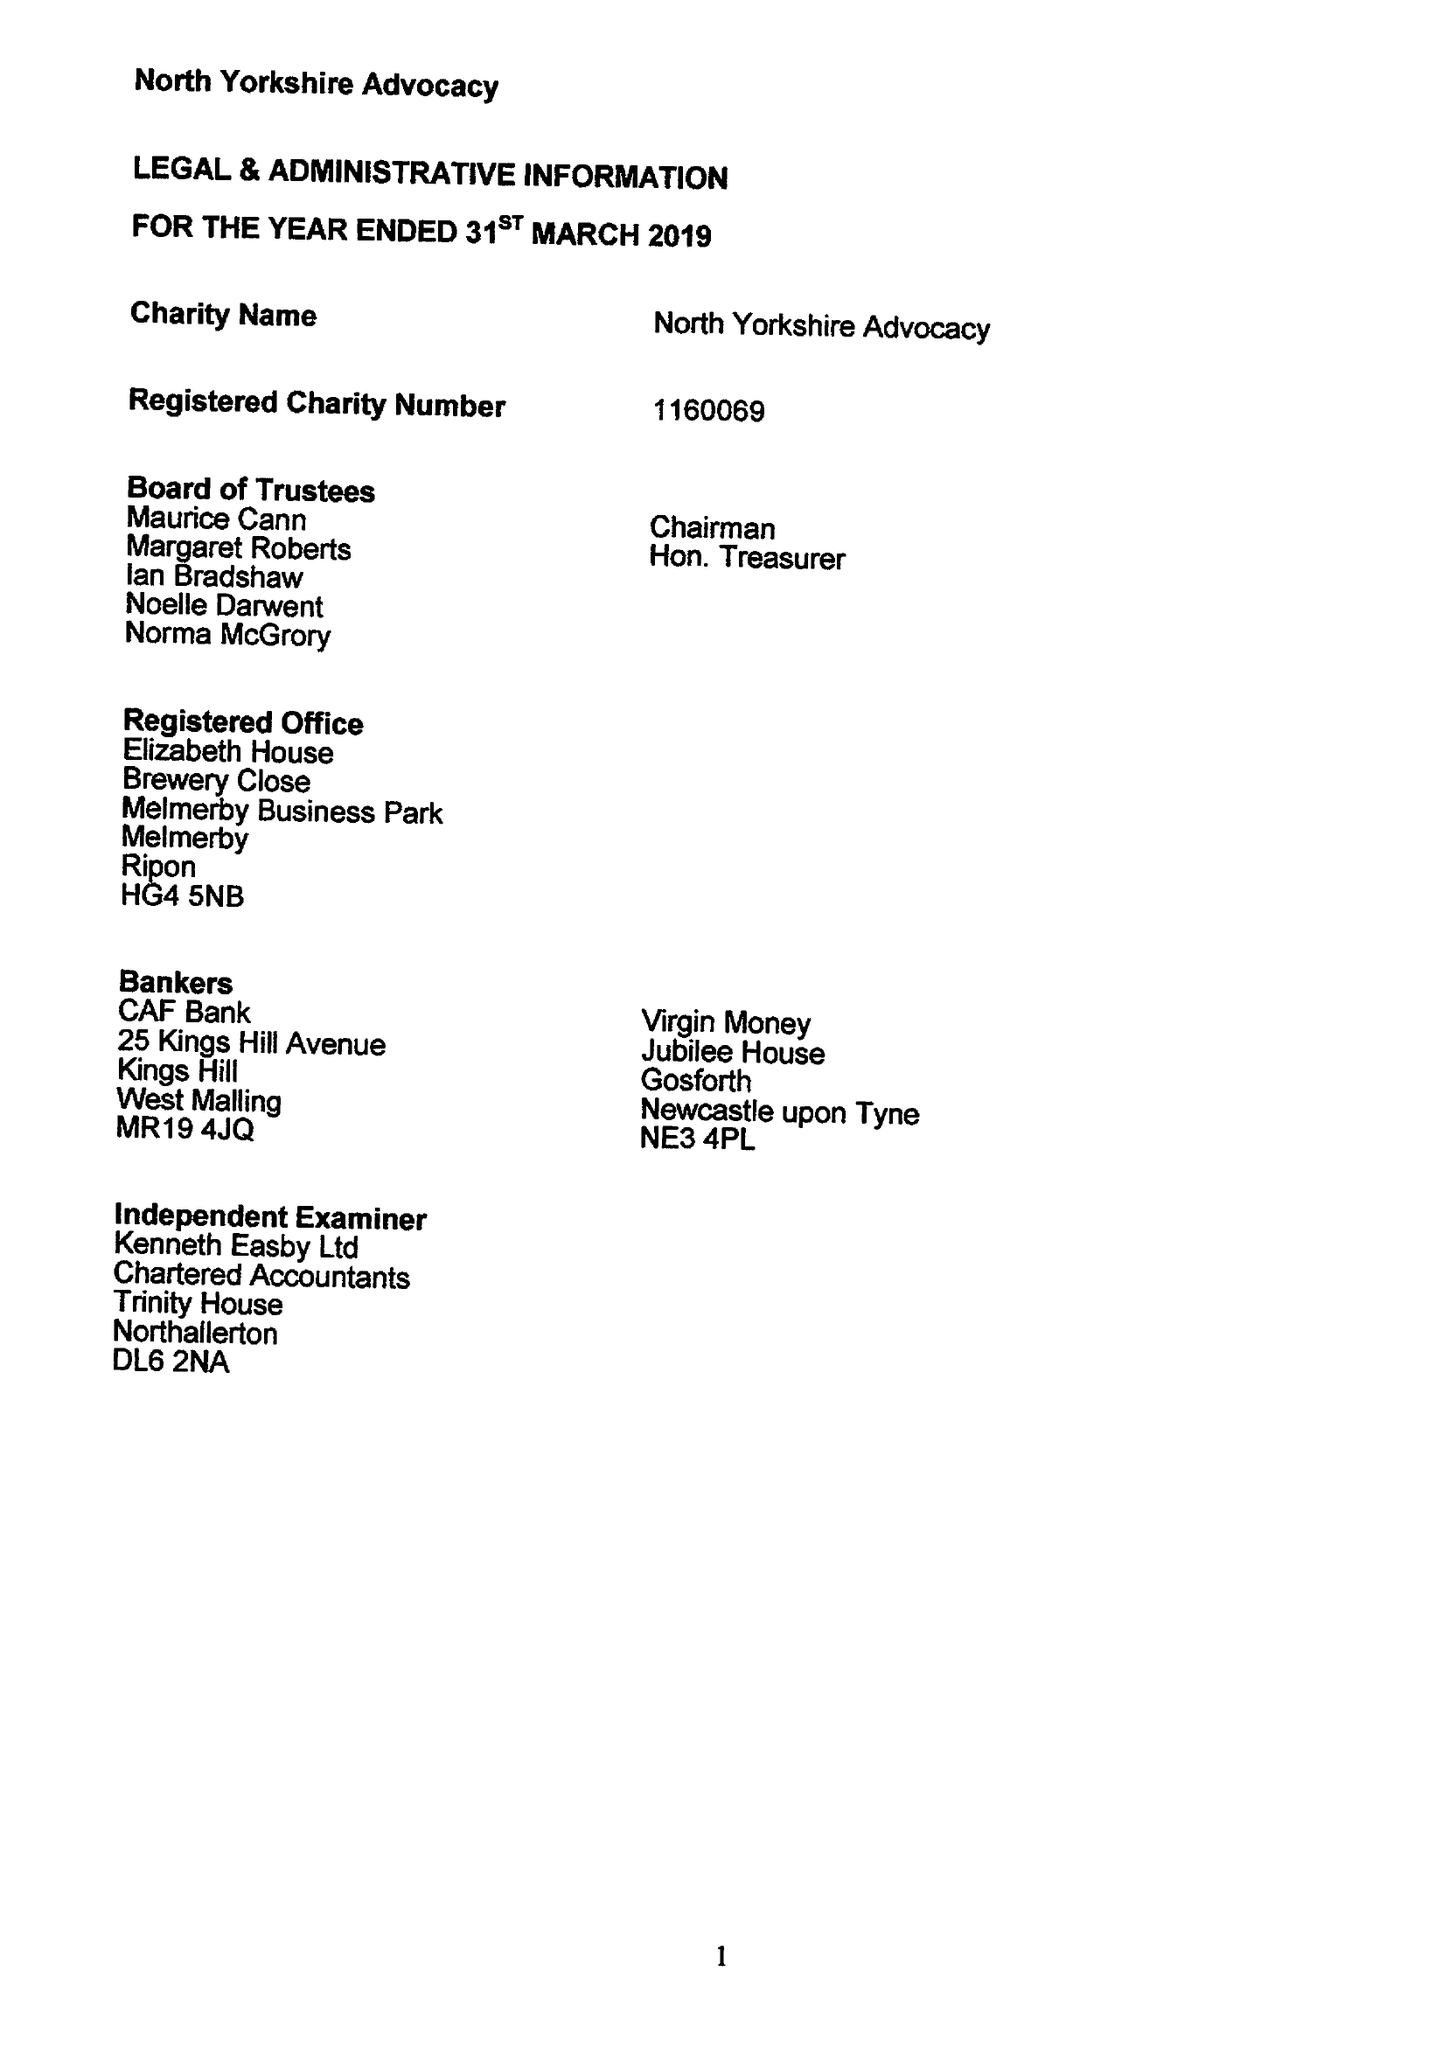What is the value for the address__postcode?
Answer the question using a single word or phrase. None 